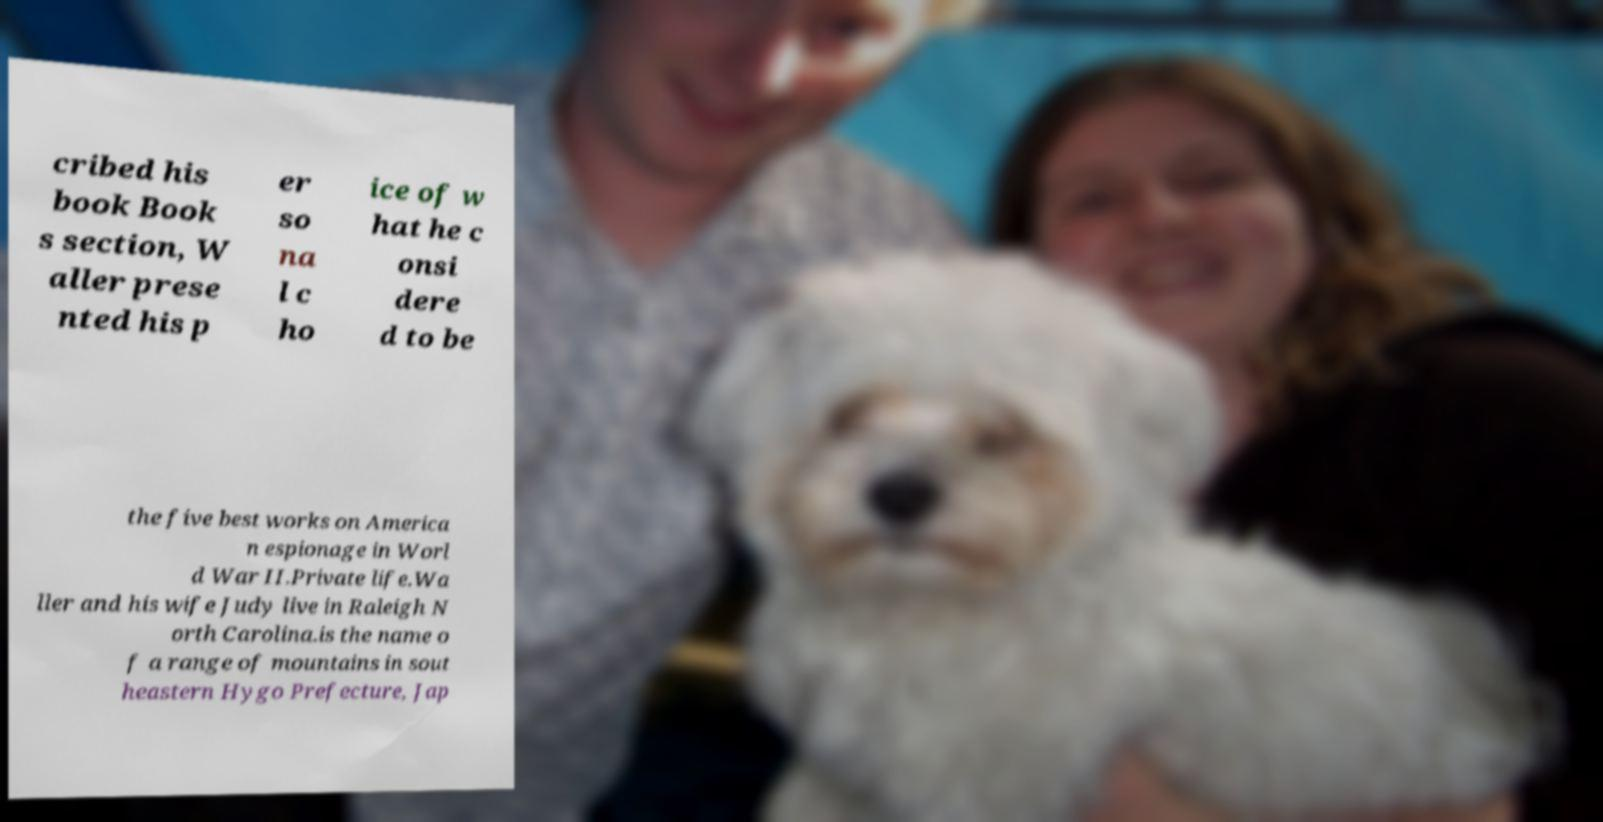Please identify and transcribe the text found in this image. cribed his book Book s section, W aller prese nted his p er so na l c ho ice of w hat he c onsi dere d to be the five best works on America n espionage in Worl d War II.Private life.Wa ller and his wife Judy live in Raleigh N orth Carolina.is the name o f a range of mountains in sout heastern Hygo Prefecture, Jap 